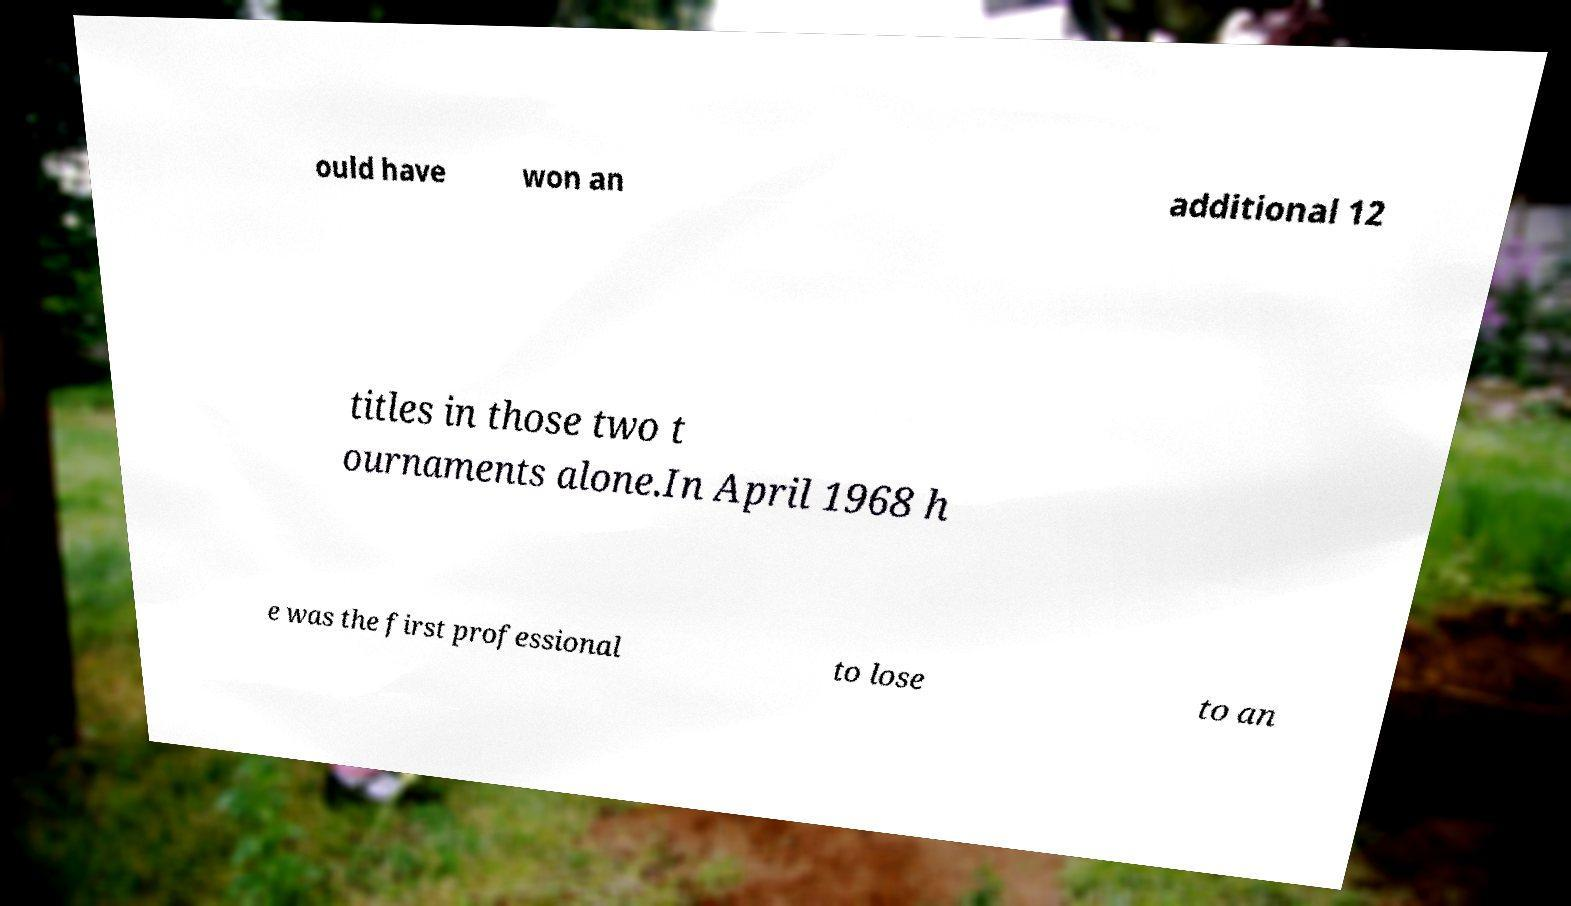Could you assist in decoding the text presented in this image and type it out clearly? ould have won an additional 12 titles in those two t ournaments alone.In April 1968 h e was the first professional to lose to an 